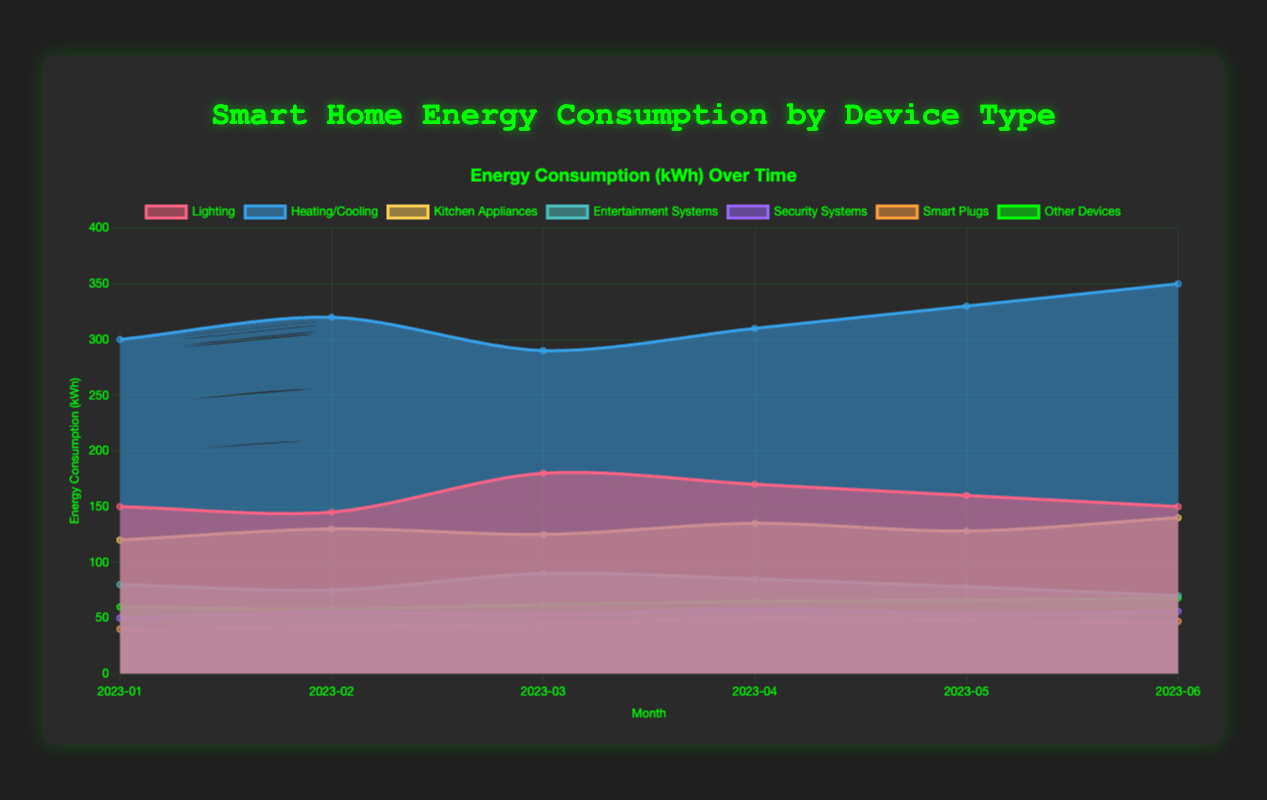What is the title of the figure? The title of a figure is typically found at the top of the chart and is meant to describe the main topic or purpose of the chart. Here, the title is "Smart Home Energy Consumption by Device Type" as seen at the top of the chart.
Answer: Smart Home Energy Consumption by Device Type What is the highest energy consumption value for Heating/Cooling, and in which month does it occur? To find the highest energy consumption for Heating/Cooling, look at the data points for this device type and identify the month with the maximum value. The highest value is 350, and it occurs in June 2023.
Answer: 350 in June 2023 Which device type has the lowest energy consumption in March 2023? To determine this, compare the energy consumption values of all device types for March 2023. The values are: Lighting (180), Heating/Cooling (290), Kitchen Appliances (125), Entertainment Systems (90), Security Systems (53), Smart Plugs (45), and Other Devices (62). The lowest value is 45, associated with Smart Plugs.
Answer: Smart Plugs How does the energy consumption of Kitchen Appliances in April 2023 compare to that in February 2023? Look at the values for Kitchen Appliances in April (135) and February (130). To compare them, subtract the February value from the April value: 135 - 130 = 5. This shows that consumption increased by 5 kWh.
Answer: Increased by 5 kWh What is the total energy consumption for Security Systems over the six months? Add up the monthly energy consumption values for Security Systems: 50 + 55 + 53 + 58 + 54 + 56. The sum is 50 + 55 + 53 + 58 + 54 + 56 = 326 kWh.
Answer: 326 kWh During which month does Lighting have the maximum energy consumption? Look at the energy consumption values for Lighting across all months. The maximum value is 180, and it occurs in March 2023.
Answer: March 2023 What is the average energy consumption for Entertainment Systems over the six months? Add the monthly values for Entertainment Systems and divide by the number of months: (80 + 75 + 90 + 85 + 78 + 70) / 6. First, sum the values: 80 + 75 + 90 + 85 + 78 + 70 = 478. Then divide by 6 to obtain the average: 478 / 6 ≈ 79.67 kWh.
Answer: Approximately 79.67 kWh Which device types show a decrease in energy consumption from January to June 2023? Compare the values from January and June for each device type. If the June value is less than the January value, it indicates a decrease. For Lighting (150 to 150), Entertainment Systems (80 to 70), Smart Plugs (40 to 47), and Other Devices (60 to 68), only Entertainment Systems shows a decrease (80 to 70).
Answer: Entertainment Systems Between Security Systems and Smart Plugs, which device type has a more significant increase in energy consumption from January to June 2023? Calculate the increase for each device type from January to June. For Security Systems: 56 - 50 = 6 kWh. For Smart Plugs: 47 - 40 = 7 kWh. Smart Plugs have a more significant increase (7 kWh) compared to Security Systems (6 kWh).
Answer: Smart Plugs What is the overall trend in energy consumption for Heating/Cooling over the six months? Look at the monthly values for Heating/Cooling: 300, 320, 290, 310, 330, 350. Notice the trend: it fluctuates but generally increases from 300 in January to 350 in June.
Answer: Increasing trend 